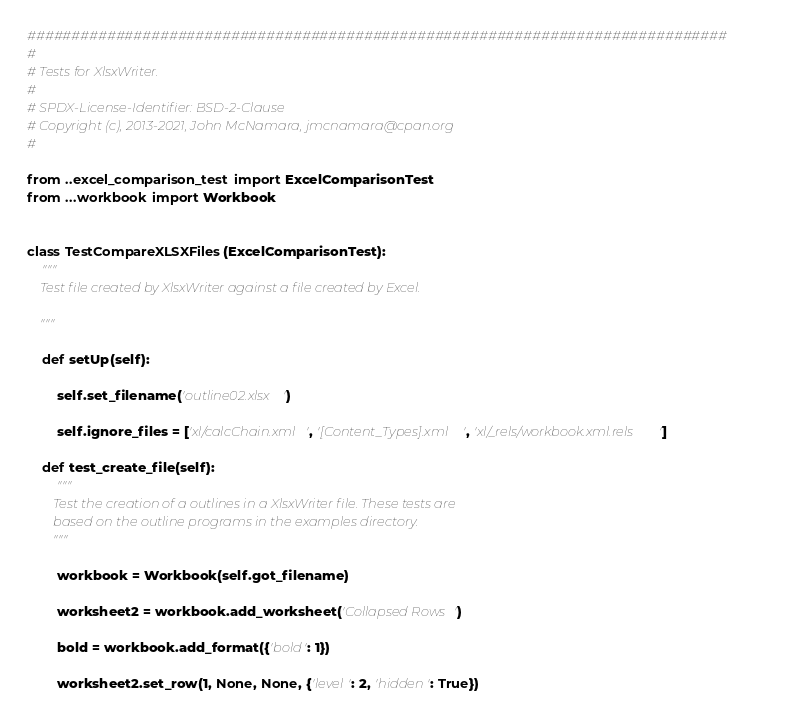<code> <loc_0><loc_0><loc_500><loc_500><_Python_>###############################################################################
#
# Tests for XlsxWriter.
#
# SPDX-License-Identifier: BSD-2-Clause
# Copyright (c), 2013-2021, John McNamara, jmcnamara@cpan.org
#

from ..excel_comparison_test import ExcelComparisonTest
from ...workbook import Workbook


class TestCompareXLSXFiles(ExcelComparisonTest):
    """
    Test file created by XlsxWriter against a file created by Excel.

    """

    def setUp(self):

        self.set_filename('outline02.xlsx')

        self.ignore_files = ['xl/calcChain.xml', '[Content_Types].xml', 'xl/_rels/workbook.xml.rels']

    def test_create_file(self):
        """
        Test the creation of a outlines in a XlsxWriter file. These tests are
        based on the outline programs in the examples directory.
        """

        workbook = Workbook(self.got_filename)

        worksheet2 = workbook.add_worksheet('Collapsed Rows')

        bold = workbook.add_format({'bold': 1})

        worksheet2.set_row(1, None, None, {'level': 2, 'hidden': True})</code> 